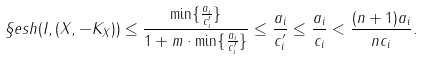Convert formula to latex. <formula><loc_0><loc_0><loc_500><loc_500>\S e s h ( I , ( X , - K _ { X } ) ) \leq \frac { \min \{ \frac { a _ { i } } { c _ { i } ^ { \prime } } \} } { 1 + m \cdot \min \{ \frac { a _ { i } } { c _ { i } ^ { \prime } } \} } \leq \frac { a _ { i } } { c _ { i } ^ { \prime } } \leq \frac { a _ { i } } { c _ { i } } < \frac { ( n + 1 ) a _ { i } } { n c _ { i } } .</formula> 